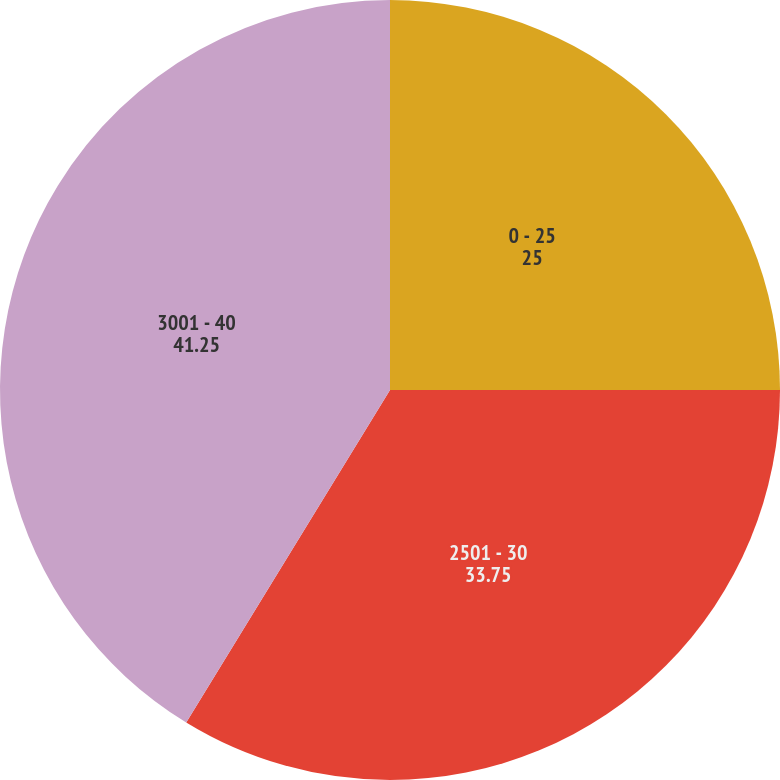<chart> <loc_0><loc_0><loc_500><loc_500><pie_chart><fcel>0 - 25<fcel>2501 - 30<fcel>3001 - 40<nl><fcel>25.0%<fcel>33.75%<fcel>41.25%<nl></chart> 